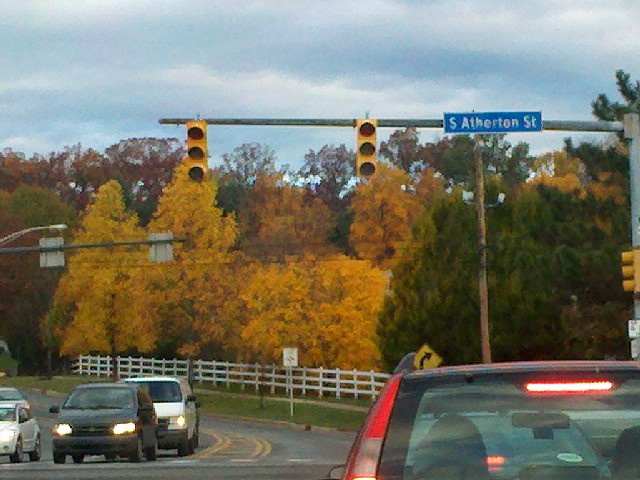Describe the objects in this image and their specific colors. I can see car in lightgray, gray, black, teal, and brown tones, car in lightgray, black, and gray tones, people in lightgray, gray, purple, and brown tones, car in lightgray, black, gray, white, and purple tones, and car in lightgray, gray, darkgray, white, and black tones in this image. 